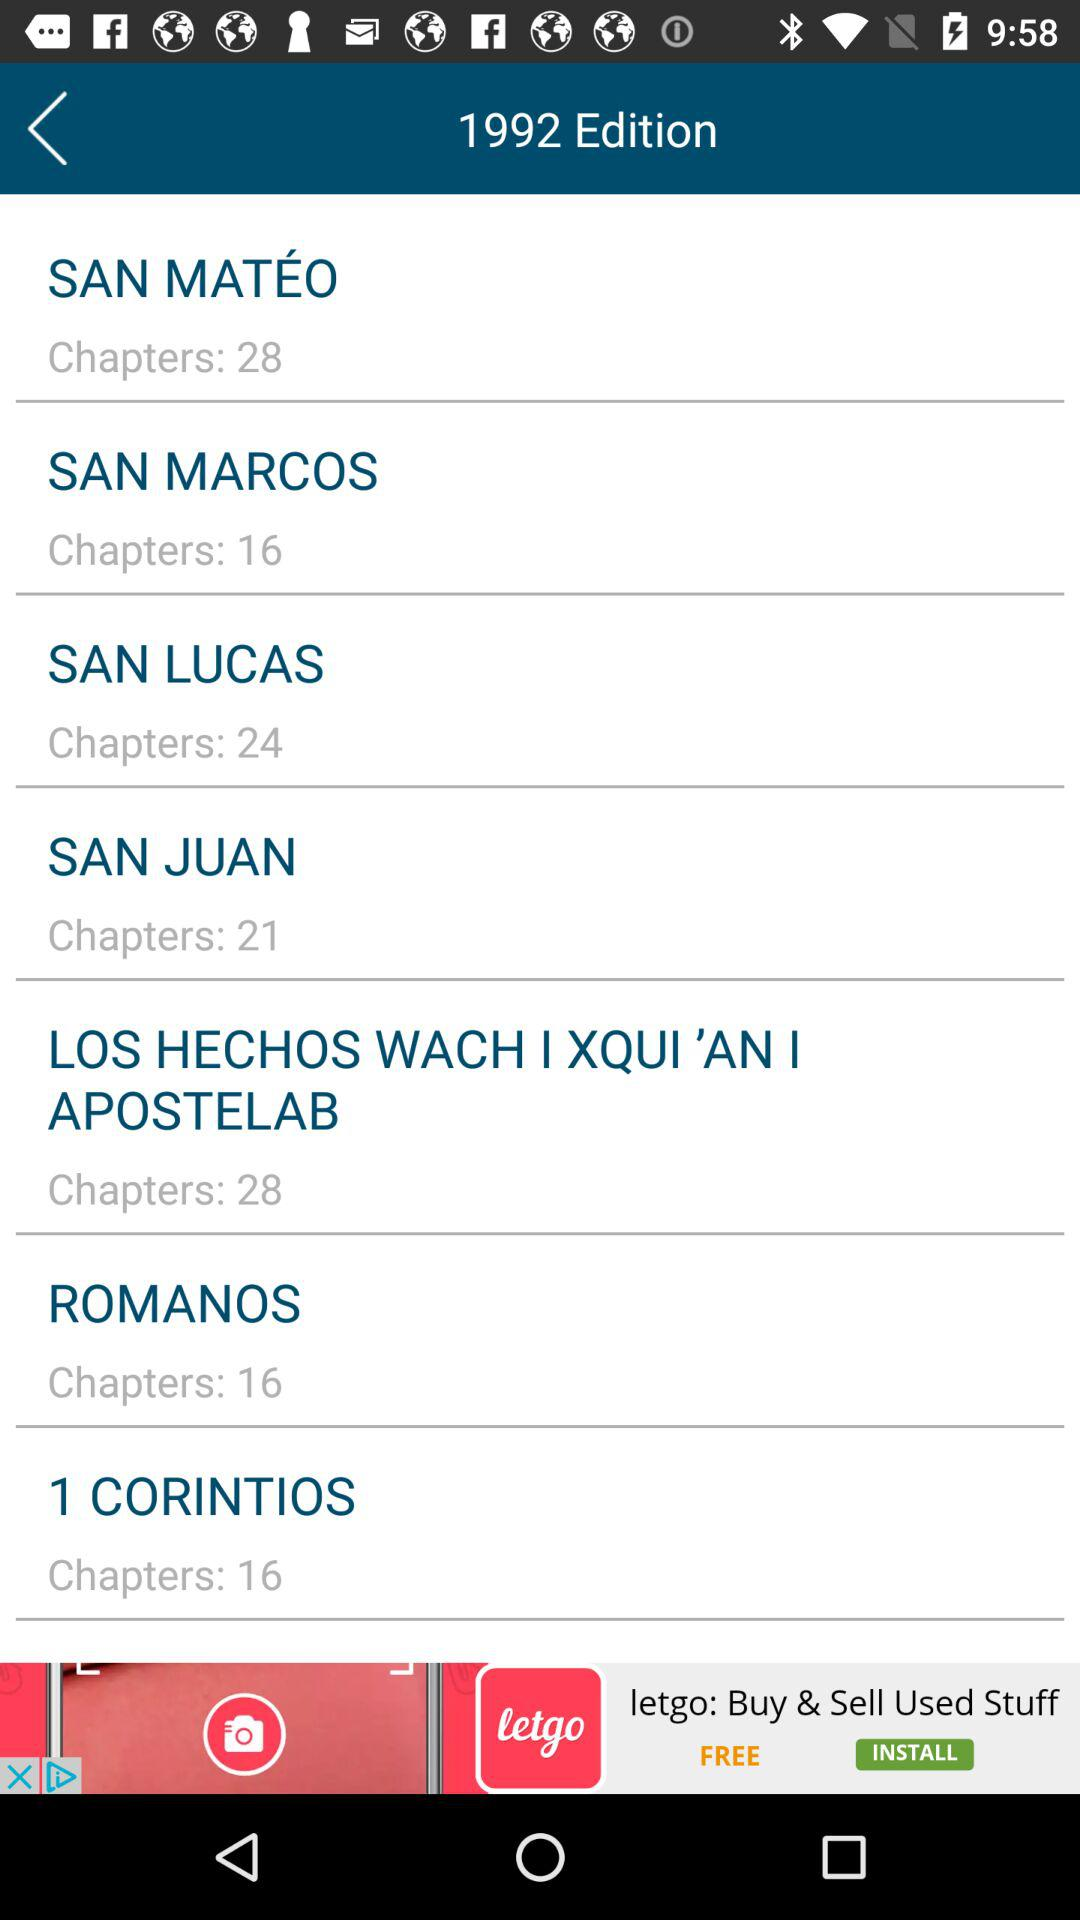What is the number of chapters in San Mateo? The number of chapters in San Mateo is 28. 